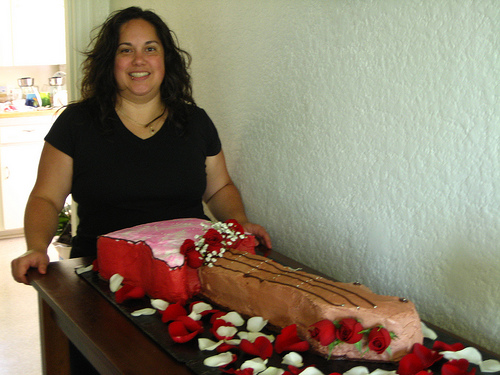<image>
Is there a smile on the lady? Yes. Looking at the image, I can see the smile is positioned on top of the lady, with the lady providing support. Where is the lady in relation to the cake? Is it on the cake? No. The lady is not positioned on the cake. They may be near each other, but the lady is not supported by or resting on top of the cake. Where is the woman in relation to the cake? Is it in the cake? No. The woman is not contained within the cake. These objects have a different spatial relationship. 